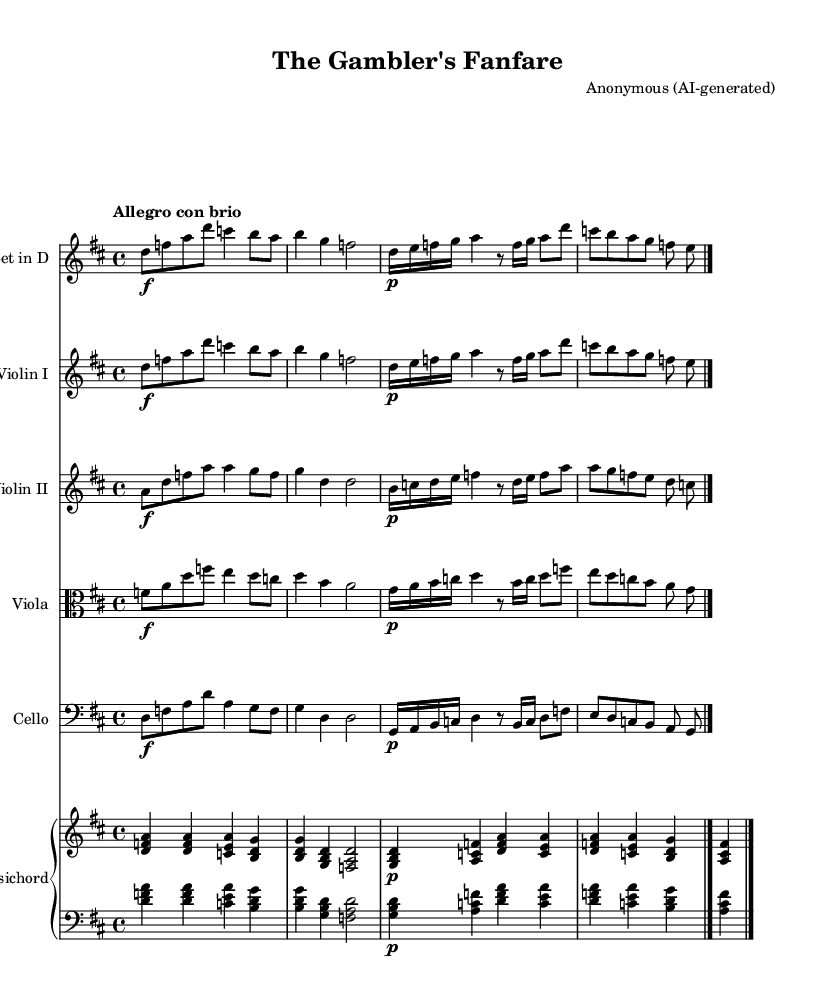What is the key signature of this music? The key signature is D major, which has two sharps (F# and C#). This can be determined by looking at the key signature indicated at the beginning of the score.
Answer: D major What is the time signature of this music? The time signature is 4/4, which means there are four beats in a measure and the quarter note receives one beat. This is indicated at the beginning of the score.
Answer: 4/4 What is the tempo marking for this piece? The tempo marking is "Allegro con brio," which suggests that the music should be played fast and with vigor. This is noted above the staff at the beginning of the score.
Answer: Allegro con brio How many measures are in the piece? There are ten measures in total, which can be counted by the vertical bar lines that indicate the end of each measure throughout the score.
Answer: 10 Which instruments are featured in this concerto? The featured instruments in this concerto are Trumpet in D, Violin I, Violin II, Viola, Cello, and Harpsichord. This can be observed from the different staves labeled at the beginning of the score.
Answer: Trumpet in D, Violin I, Violin II, Viola, Cello, Harpsichord What type of musical work is this piece? This piece is a concerto, specifically written for trumpet and strings, which is characteristic of the Baroque style that often features concertos and showcases solo instruments.
Answer: Concerto What is the dynamic marking for the trumpet in the first measure? The dynamic marking for the trumpet in the first measure is forte (f), indicating that it should be played loudly. This is shown directly in the notation for the trumpet part.
Answer: Forte 